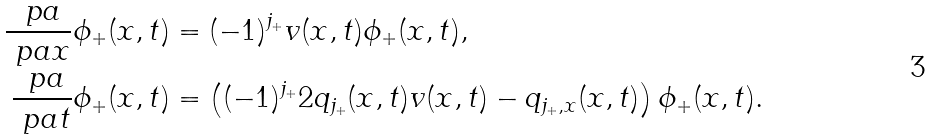Convert formula to latex. <formula><loc_0><loc_0><loc_500><loc_500>\frac { \ p a } { \ p a x } \phi _ { + } ( x , t ) & = ( - 1 ) ^ { j _ { + } } v ( x , t ) \phi _ { + } ( x , t ) , \\ \frac { \ p a } { \ p a t } \phi _ { + } ( x , t ) & = \left ( ( - 1 ) ^ { j _ { + } } 2 q _ { j _ { + } } ( x , t ) v ( x , t ) - q _ { j _ { + } , x } ( x , t ) \right ) \phi _ { + } ( x , t ) .</formula> 